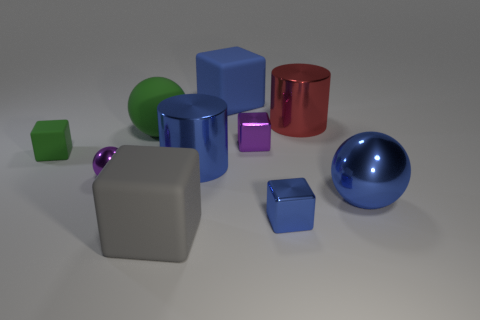Subtract all red spheres. How many blue cubes are left? 2 Subtract all small blue shiny cubes. How many cubes are left? 4 Subtract all gray blocks. How many blocks are left? 4 Subtract 2 cubes. How many cubes are left? 3 Subtract all brown cubes. Subtract all red cylinders. How many cubes are left? 5 Subtract all balls. How many objects are left? 7 Subtract all large brown rubber cylinders. Subtract all blue balls. How many objects are left? 9 Add 7 tiny green cubes. How many tiny green cubes are left? 8 Add 4 gray matte things. How many gray matte things exist? 5 Subtract 1 red cylinders. How many objects are left? 9 